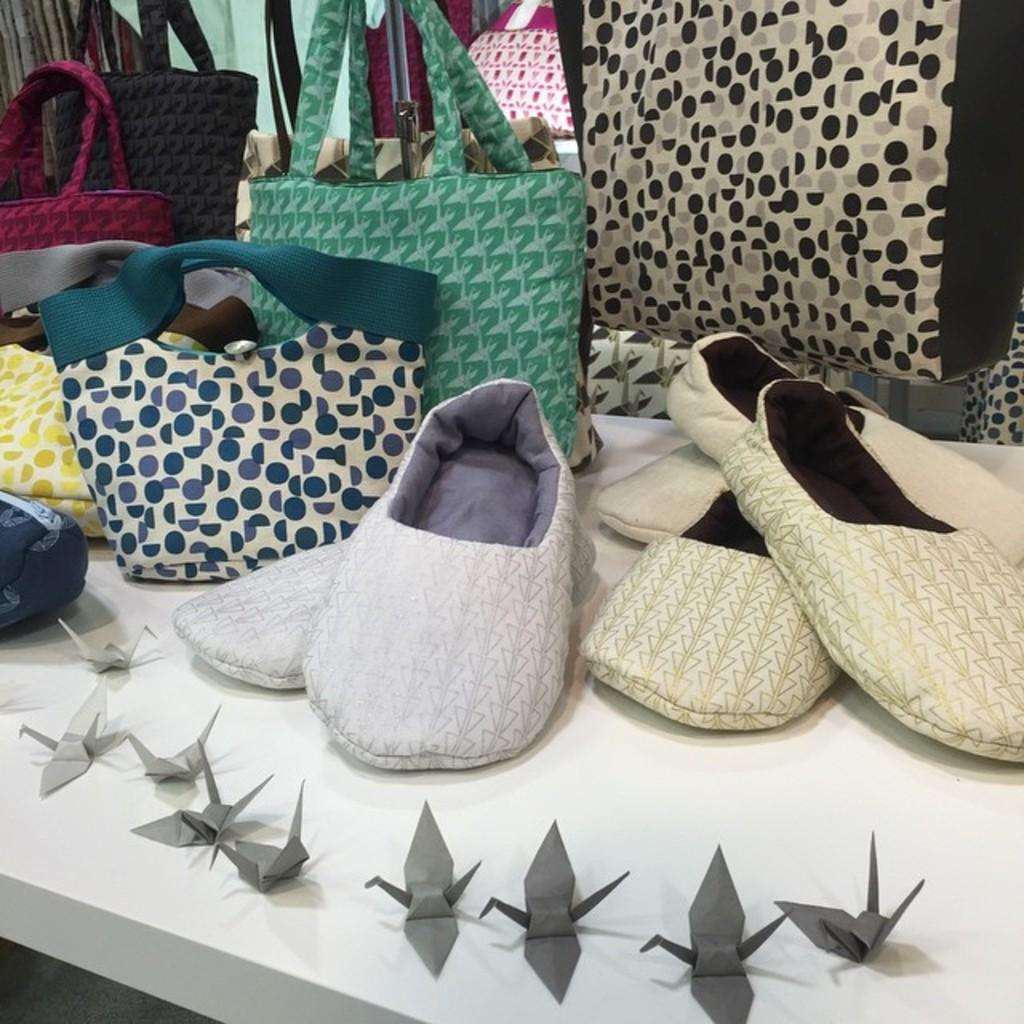What objects are placed on the table in the image? There are bags and footwear on the table in the image. Can you describe the bags on the table? The provided facts do not give any details about the bags, so we cannot describe them further. What type of footwear is on the table? The provided facts do not specify the type of footwear on the table. What type of island can be seen in the background of the image? There is no island present in the image; it only features bags and footwear on a table. What time of day is it in the image, considering the afternoon? The provided facts do not give any information about the time of day, so we cannot determine if it is afternoon or not. 